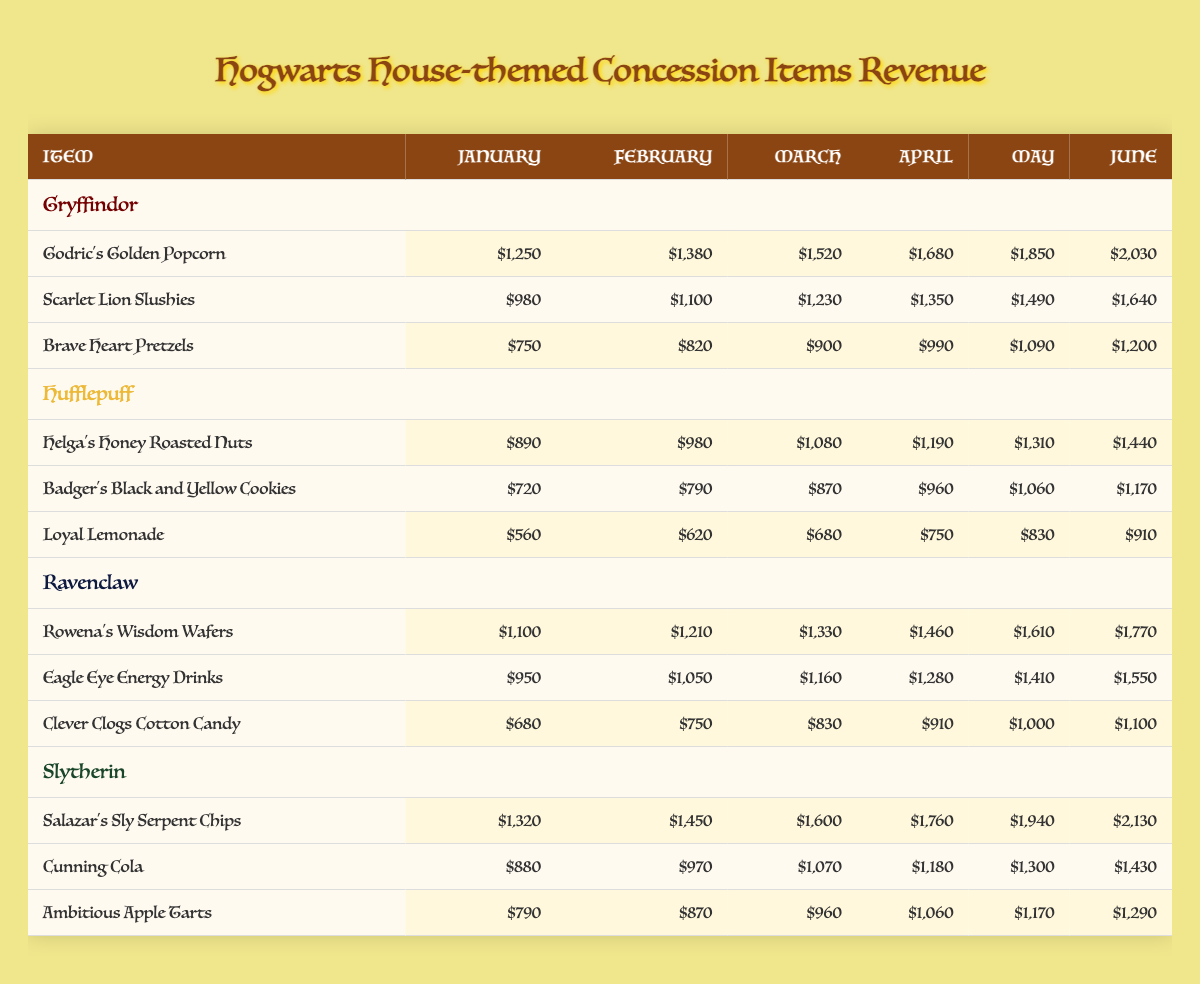What is the revenue for "Godric's Golden Popcorn" in March? The revenue for "Godric's Golden Popcorn" is listed under the Gryffindor items in the March column, which shows a value of $1,520.
Answer: $1,520 Which house had the least revenue from "Clever Clogs Cotton Candy"? The revenue from "Clever Clogs Cotton Candy" for each month is shown in the table, with values of $680, $750, $830, $910, $1,000, and $1,100. Since this is the only item in its category for Ravenclaw, it has the least revenue compared to other items for different houses.
Answer: Yes What is the total revenue for all Hufflepuff items in June? For Hufflepuff items in June, the revenues are $1,440 (Helga's Honey Roasted Nuts), $1,170 (Badger's Black and Yellow Cookies), and $910 (Loyal Lemonade). Adding these values: $1,440 + $1,170 + $910 = $3,520.
Answer: $3,520 Did Slytherin have higher revenue than Gryffindor in every month? To determine this, we compare the total revenues for each month for both houses. In each month, Gryffindor values are $1,250, $1,380, $1,520, $1,680, $1,850, $2,030, while Slytherin's values are $1,320, $1,450, $1,600, $1,760, $1,940, $2,130. In January, February, and March, Slytherin is higher, but in April, May, and June, Gryffindor exceeds Slytherin. Therefore, the answer is no.
Answer: No What is the average revenue for Ravenclaw items in May? The Ravenclaw items for May are: $1,610 (Rowena's Wisdom Wafers), $1,410 (Eagle Eye Energy Drinks), and $1,000 (Clever Clogs Cotton Candy). The total revenue is $1,610 + $1,410 + $1,000 = $4,020. Dividing by the number of items, which is 3, gives an average of $4,020 / 3 = $1,340.
Answer: $1,340 